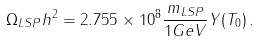Convert formula to latex. <formula><loc_0><loc_0><loc_500><loc_500>\Omega _ { L S P } h ^ { 2 } = 2 . 7 5 5 \times 1 0 ^ { 8 } \frac { m _ { L S P } } { 1 G e V } Y ( T _ { 0 } ) \, .</formula> 